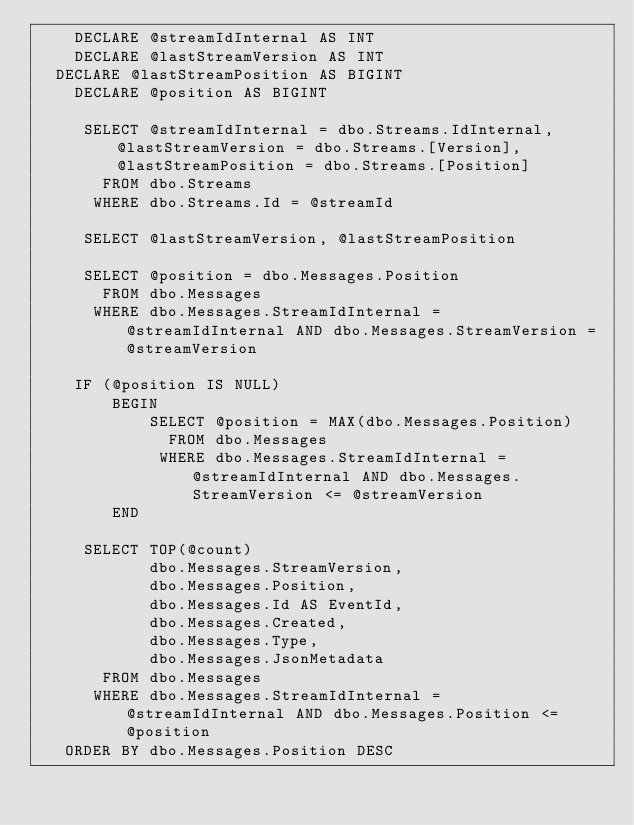<code> <loc_0><loc_0><loc_500><loc_500><_SQL_>    DECLARE @streamIdInternal AS INT
    DECLARE @lastStreamVersion AS INT
	DECLARE @lastStreamPosition AS BIGINT
    DECLARE @position AS BIGINT

     SELECT @streamIdInternal = dbo.Streams.IdInternal, @lastStreamVersion = dbo.Streams.[Version], @lastStreamPosition = dbo.Streams.[Position]
       FROM dbo.Streams
      WHERE dbo.Streams.Id = @streamId

     SELECT @lastStreamVersion, @lastStreamPosition

     SELECT @position = dbo.Messages.Position
       FROM dbo.Messages 
      WHERE dbo.Messages.StreamIdInternal = @streamIdInternal AND dbo.Messages.StreamVersion = @streamVersion
    
    IF (@position IS NULL)
        BEGIN
            SELECT @position = MAX(dbo.Messages.Position)
              FROM dbo.Messages 
             WHERE dbo.Messages.StreamIdInternal = @streamIdInternal AND dbo.Messages.StreamVersion <= @streamVersion
        END

     SELECT TOP(@count)
            dbo.Messages.StreamVersion,
            dbo.Messages.Position,
            dbo.Messages.Id AS EventId,
            dbo.Messages.Created,
            dbo.Messages.Type,
            dbo.Messages.JsonMetadata
       FROM dbo.Messages
      WHERE dbo.Messages.StreamIdInternal = @streamIdInternal AND dbo.Messages.Position <= @position
   ORDER BY dbo.Messages.Position DESC
</code> 